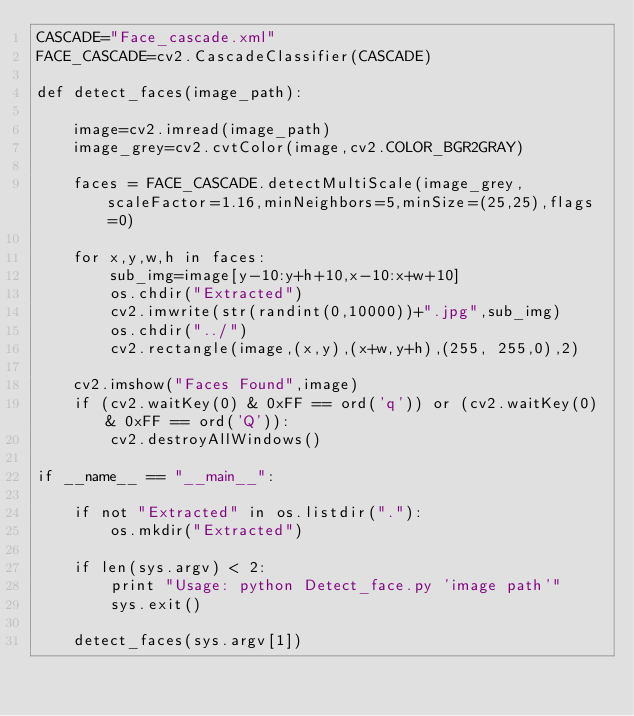Convert code to text. <code><loc_0><loc_0><loc_500><loc_500><_Python_>CASCADE="Face_cascade.xml"
FACE_CASCADE=cv2.CascadeClassifier(CASCADE)

def detect_faces(image_path):

	image=cv2.imread(image_path)
	image_grey=cv2.cvtColor(image,cv2.COLOR_BGR2GRAY)

	faces = FACE_CASCADE.detectMultiScale(image_grey,scaleFactor=1.16,minNeighbors=5,minSize=(25,25),flags=0)

	for x,y,w,h in faces:
	    sub_img=image[y-10:y+h+10,x-10:x+w+10]
	    os.chdir("Extracted")
	    cv2.imwrite(str(randint(0,10000))+".jpg",sub_img)
	    os.chdir("../")
	    cv2.rectangle(image,(x,y),(x+w,y+h),(255, 255,0),2)

	cv2.imshow("Faces Found",image)
	if (cv2.waitKey(0) & 0xFF == ord('q')) or (cv2.waitKey(0) & 0xFF == ord('Q')):
		cv2.destroyAllWindows()

if __name__ == "__main__":
	
	if not "Extracted" in os.listdir("."):
		os.mkdir("Extracted")
    
	if len(sys.argv) < 2:
		print "Usage: python Detect_face.py 'image path'"
		sys.exit()

	detect_faces(sys.argv[1])</code> 